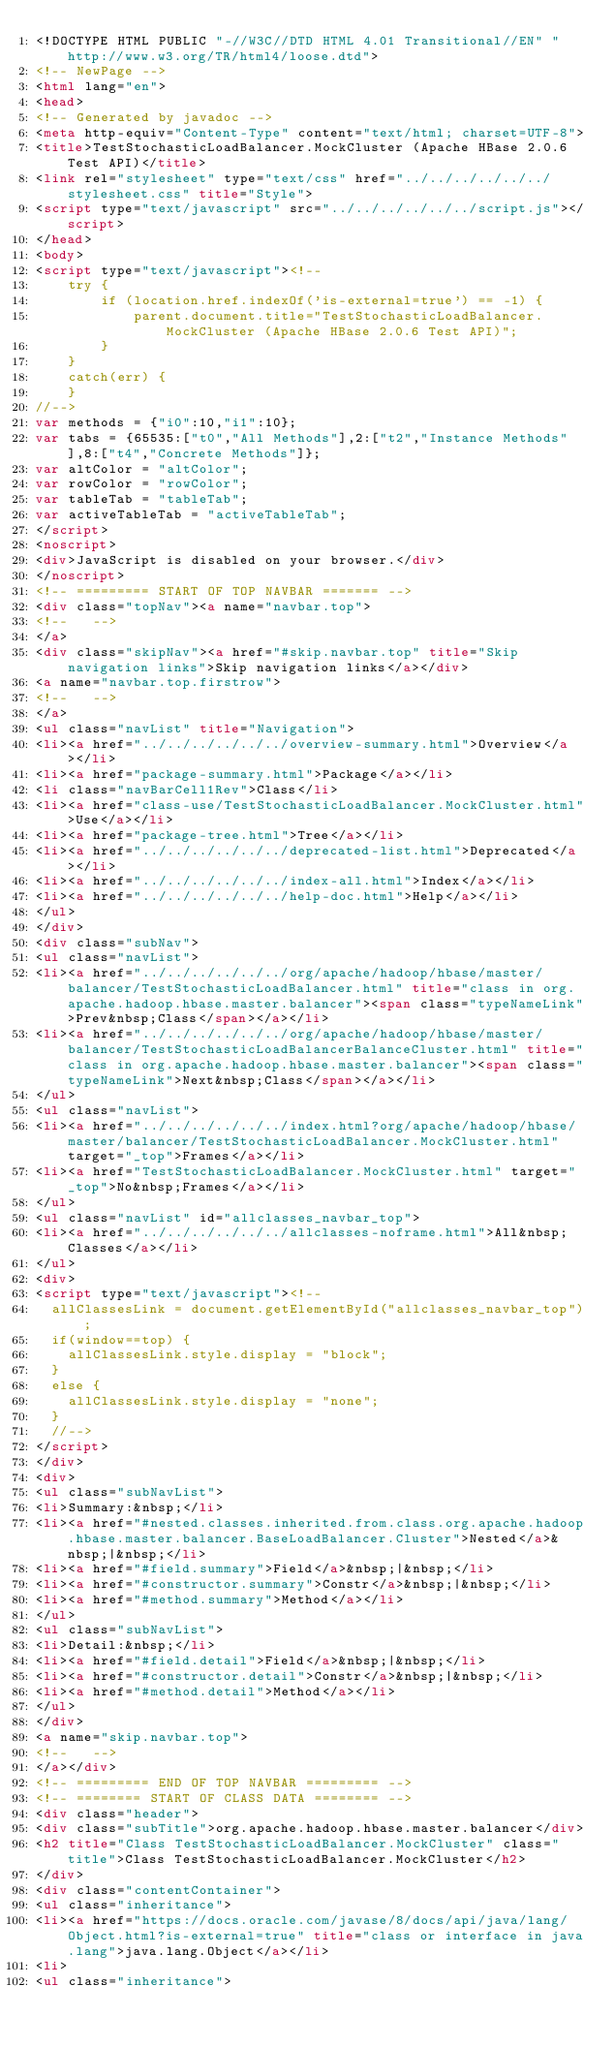<code> <loc_0><loc_0><loc_500><loc_500><_HTML_><!DOCTYPE HTML PUBLIC "-//W3C//DTD HTML 4.01 Transitional//EN" "http://www.w3.org/TR/html4/loose.dtd">
<!-- NewPage -->
<html lang="en">
<head>
<!-- Generated by javadoc -->
<meta http-equiv="Content-Type" content="text/html; charset=UTF-8">
<title>TestStochasticLoadBalancer.MockCluster (Apache HBase 2.0.6 Test API)</title>
<link rel="stylesheet" type="text/css" href="../../../../../../stylesheet.css" title="Style">
<script type="text/javascript" src="../../../../../../script.js"></script>
</head>
<body>
<script type="text/javascript"><!--
    try {
        if (location.href.indexOf('is-external=true') == -1) {
            parent.document.title="TestStochasticLoadBalancer.MockCluster (Apache HBase 2.0.6 Test API)";
        }
    }
    catch(err) {
    }
//-->
var methods = {"i0":10,"i1":10};
var tabs = {65535:["t0","All Methods"],2:["t2","Instance Methods"],8:["t4","Concrete Methods"]};
var altColor = "altColor";
var rowColor = "rowColor";
var tableTab = "tableTab";
var activeTableTab = "activeTableTab";
</script>
<noscript>
<div>JavaScript is disabled on your browser.</div>
</noscript>
<!-- ========= START OF TOP NAVBAR ======= -->
<div class="topNav"><a name="navbar.top">
<!--   -->
</a>
<div class="skipNav"><a href="#skip.navbar.top" title="Skip navigation links">Skip navigation links</a></div>
<a name="navbar.top.firstrow">
<!--   -->
</a>
<ul class="navList" title="Navigation">
<li><a href="../../../../../../overview-summary.html">Overview</a></li>
<li><a href="package-summary.html">Package</a></li>
<li class="navBarCell1Rev">Class</li>
<li><a href="class-use/TestStochasticLoadBalancer.MockCluster.html">Use</a></li>
<li><a href="package-tree.html">Tree</a></li>
<li><a href="../../../../../../deprecated-list.html">Deprecated</a></li>
<li><a href="../../../../../../index-all.html">Index</a></li>
<li><a href="../../../../../../help-doc.html">Help</a></li>
</ul>
</div>
<div class="subNav">
<ul class="navList">
<li><a href="../../../../../../org/apache/hadoop/hbase/master/balancer/TestStochasticLoadBalancer.html" title="class in org.apache.hadoop.hbase.master.balancer"><span class="typeNameLink">Prev&nbsp;Class</span></a></li>
<li><a href="../../../../../../org/apache/hadoop/hbase/master/balancer/TestStochasticLoadBalancerBalanceCluster.html" title="class in org.apache.hadoop.hbase.master.balancer"><span class="typeNameLink">Next&nbsp;Class</span></a></li>
</ul>
<ul class="navList">
<li><a href="../../../../../../index.html?org/apache/hadoop/hbase/master/balancer/TestStochasticLoadBalancer.MockCluster.html" target="_top">Frames</a></li>
<li><a href="TestStochasticLoadBalancer.MockCluster.html" target="_top">No&nbsp;Frames</a></li>
</ul>
<ul class="navList" id="allclasses_navbar_top">
<li><a href="../../../../../../allclasses-noframe.html">All&nbsp;Classes</a></li>
</ul>
<div>
<script type="text/javascript"><!--
  allClassesLink = document.getElementById("allclasses_navbar_top");
  if(window==top) {
    allClassesLink.style.display = "block";
  }
  else {
    allClassesLink.style.display = "none";
  }
  //-->
</script>
</div>
<div>
<ul class="subNavList">
<li>Summary:&nbsp;</li>
<li><a href="#nested.classes.inherited.from.class.org.apache.hadoop.hbase.master.balancer.BaseLoadBalancer.Cluster">Nested</a>&nbsp;|&nbsp;</li>
<li><a href="#field.summary">Field</a>&nbsp;|&nbsp;</li>
<li><a href="#constructor.summary">Constr</a>&nbsp;|&nbsp;</li>
<li><a href="#method.summary">Method</a></li>
</ul>
<ul class="subNavList">
<li>Detail:&nbsp;</li>
<li><a href="#field.detail">Field</a>&nbsp;|&nbsp;</li>
<li><a href="#constructor.detail">Constr</a>&nbsp;|&nbsp;</li>
<li><a href="#method.detail">Method</a></li>
</ul>
</div>
<a name="skip.navbar.top">
<!--   -->
</a></div>
<!-- ========= END OF TOP NAVBAR ========= -->
<!-- ======== START OF CLASS DATA ======== -->
<div class="header">
<div class="subTitle">org.apache.hadoop.hbase.master.balancer</div>
<h2 title="Class TestStochasticLoadBalancer.MockCluster" class="title">Class TestStochasticLoadBalancer.MockCluster</h2>
</div>
<div class="contentContainer">
<ul class="inheritance">
<li><a href="https://docs.oracle.com/javase/8/docs/api/java/lang/Object.html?is-external=true" title="class or interface in java.lang">java.lang.Object</a></li>
<li>
<ul class="inheritance"></code> 